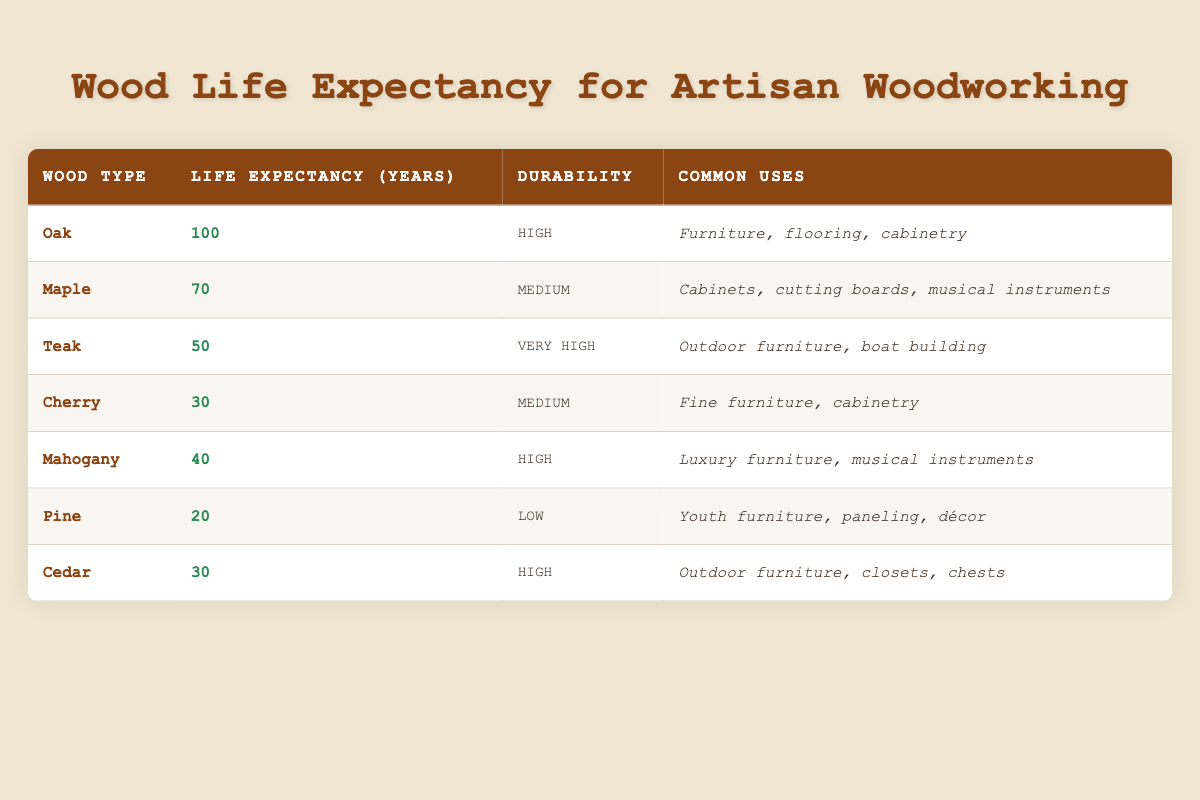What is the life expectancy of Pine? The life expectancy of Pine is clearly listed in the table under the "Life Expectancy (Years)" column for Pine, which states it is 20 years.
Answer: 20 years Which wood type has the highest life expectancy? By examining the "Life Expectancy (Years)" column, Oak is shown to have the highest life expectancy, at 100 years, surpassing all other wood types listed.
Answer: Oak Is Cherry wood more durable than Cedar wood? Looking at the "Durability" column, Cherry is categorized as having a Medium durability, while Cedar has a High durability. Therefore, Cedar is more durable than Cherry.
Answer: No What is the average life expectancy of all the woods listed? To find the average, sum the life expectancies: 100 + 70 + 50 + 30 + 40 + 20 + 30 = 340. Then divide by the number of wood types, which is 7 (340 / 7 = 48.57), so the average life expectancy is approximately 49 years.
Answer: 49 years How many wood types have a life expectancy of 30 years or less? By reviewing the "Life Expectancy (Years)" column, both Cherry (30 years) and Pine (20 years) fall under this threshold. Therefore, there are two wood types that have a life expectancy of 30 years or less.
Answer: 2 types Is Teak used in making cabinets? Referring to the "Common Uses" column for Teak, its listed uses include outdoor furniture and boat building but do not mention cabinets. Thus, it is not commonly used for that purpose.
Answer: No Which wood type has very high durability but does not correspond to the highest life expectancy? The only wood type listed with "Very High" durability is Teak, which has a life expectancy of 50 years. Other wood types with long life expectancy do not match this combination.
Answer: Teak What is the difference between the life expectancies of Oak and Mahogany? Oak has a life expectancy of 100 years, while Mahogany has a life expectancy of 40 years. The difference is calculated by subtracting Mahogany's life expectancy from Oak's: 100 - 40 = 60 years.
Answer: 60 years 